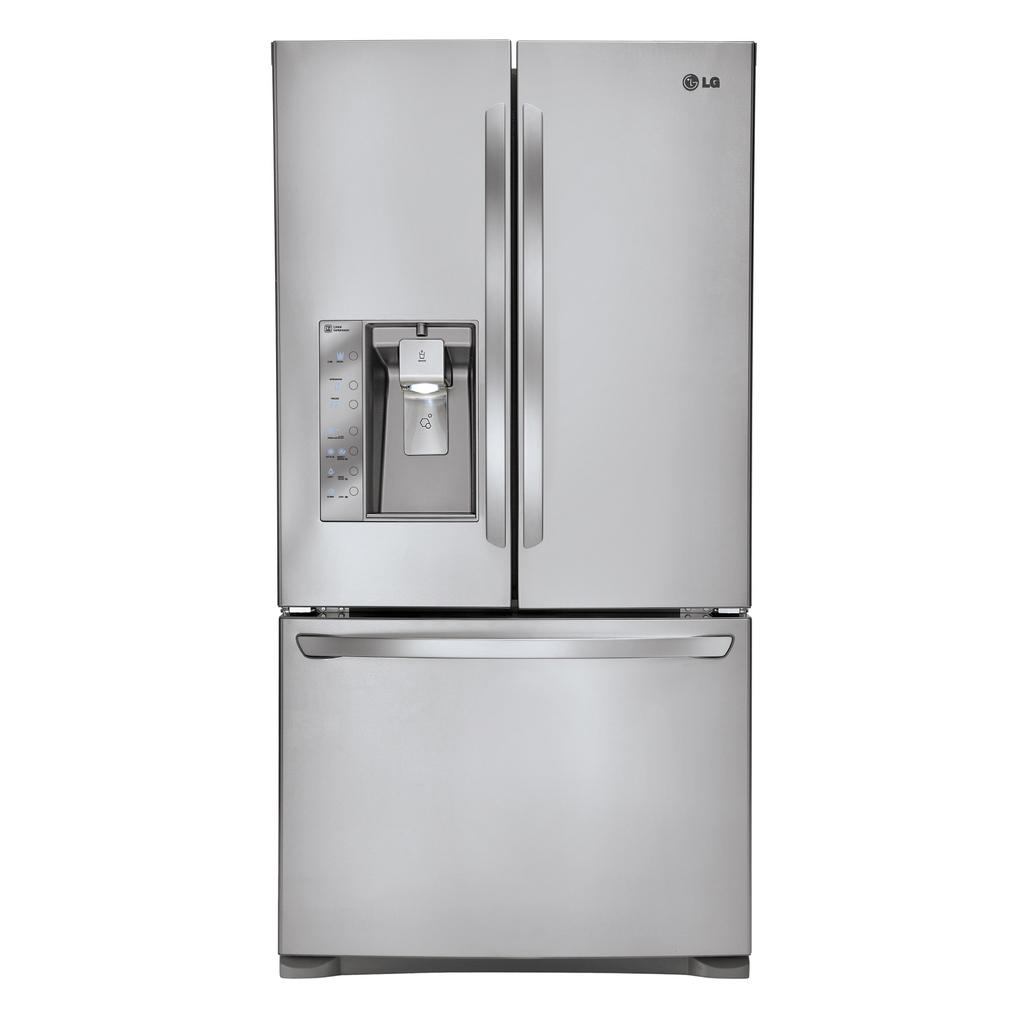Provide a one-sentence caption for the provided image. LG fridge that is brand new with a ice freezer on the left. 